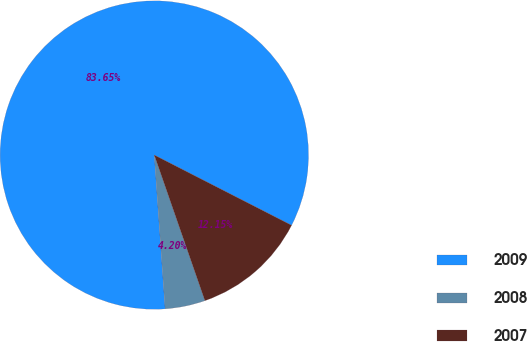Convert chart. <chart><loc_0><loc_0><loc_500><loc_500><pie_chart><fcel>2009<fcel>2008<fcel>2007<nl><fcel>83.65%<fcel>4.2%<fcel>12.15%<nl></chart> 